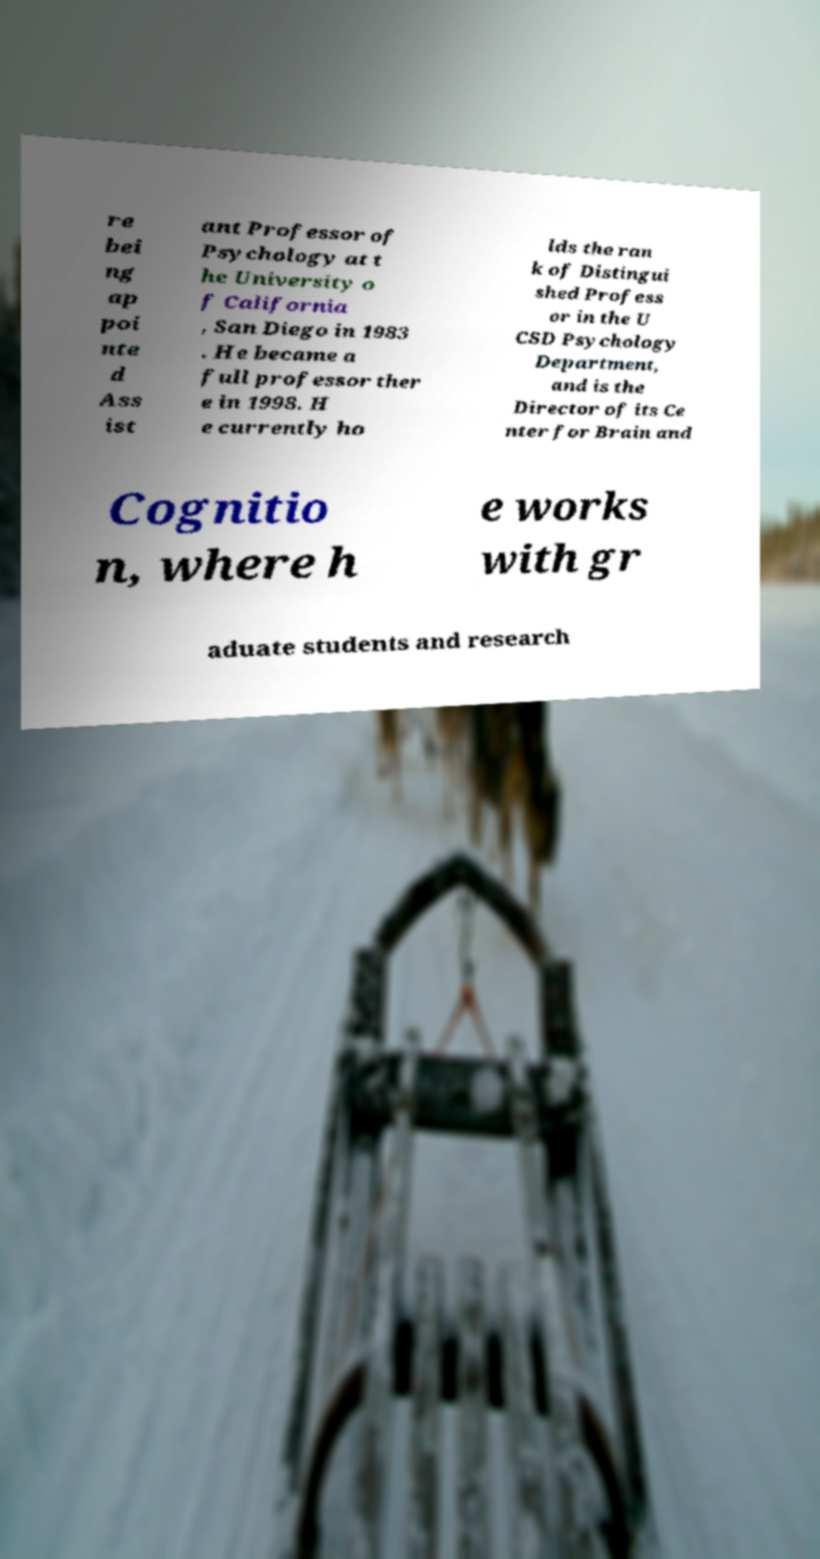Please identify and transcribe the text found in this image. re bei ng ap poi nte d Ass ist ant Professor of Psychology at t he University o f California , San Diego in 1983 . He became a full professor ther e in 1998. H e currently ho lds the ran k of Distingui shed Profess or in the U CSD Psychology Department, and is the Director of its Ce nter for Brain and Cognitio n, where h e works with gr aduate students and research 